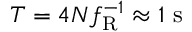Convert formula to latex. <formula><loc_0><loc_0><loc_500><loc_500>T = 4 N f _ { R } ^ { - 1 } \approx 1 s</formula> 